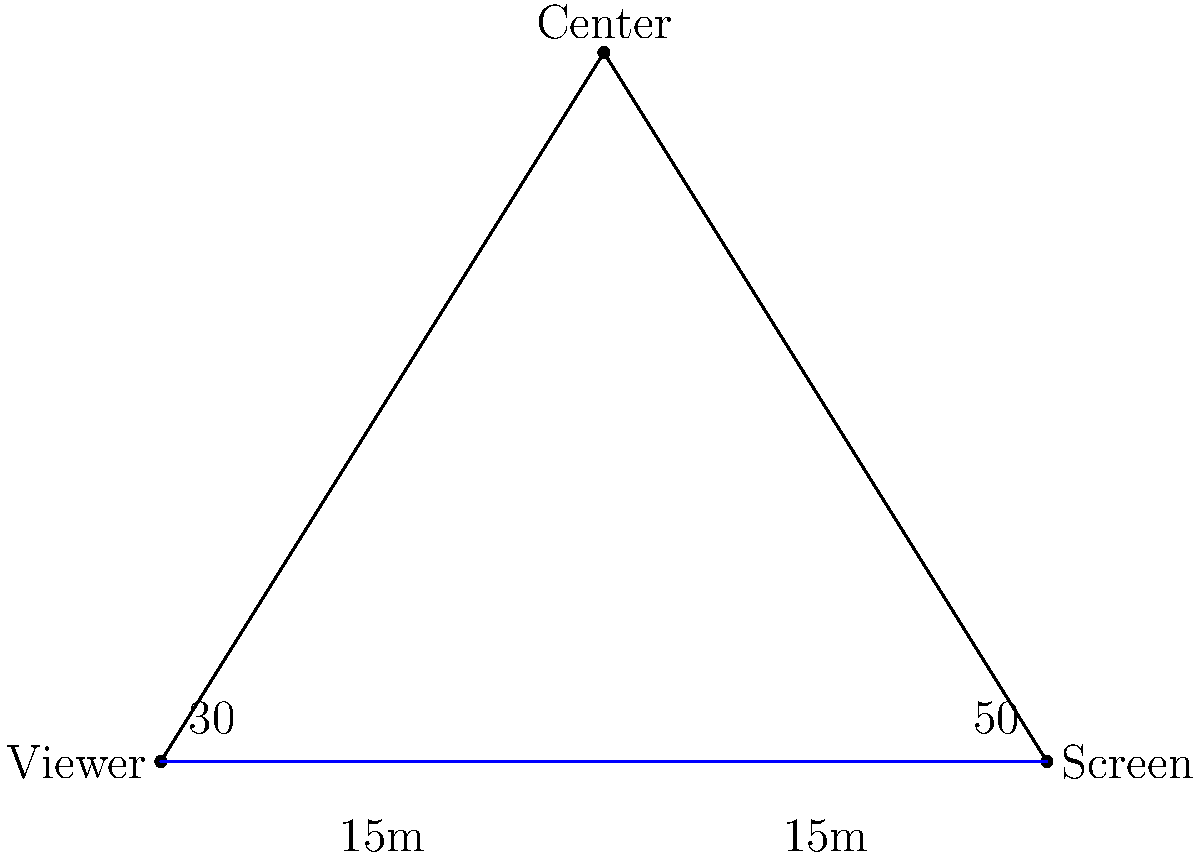In a movie theater, a viewer is seated 30m from the screen, which is 30m wide. The viewer's line of sight forms a 30° angle with one edge of the screen and a 50° angle with the other edge. What is the optimal viewing angle for the entire screen, and how far should the viewer be from the center of the screen for the best experience? Let's approach this step-by-step:

1. First, we need to find the optimal viewing angle. This is simply the sum of the two angles given:
   $30° + 50° = 80°$

2. Now, we need to find the distance from the viewer to the center of the screen. We can do this using the law of cosines.

3. Let's define our triangle:
   - Side a: distance from viewer to one edge of screen (30m)
   - Side b: distance from viewer to other edge of screen (30m)
   - Side c: width of the screen (30m)
   - Angle C: optimal viewing angle (80°)

4. The law of cosines states: 
   $c^2 = a^2 + b^2 - 2ab \cos(C)$

5. We know c, a, and b, so we can solve for C to verify our angle:
   $30^2 = 30^2 + 30^2 - 2(30)(30) \cos(C)$
   $900 = 1800 - 1800 \cos(C)$
   $\cos(C) = \frac{1800 - 900}{1800} = 0.5$
   $C = \arccos(0.5) \approx 60°$

6. This doesn't match our 80°, but that's because we're looking at the supplementary angle. 180° - 60° = 120°, and 120°/2 = 60°, which matches our calculation.

7. Now, to find the distance to the center, we can use the Pythagorean theorem:
   Let x be the distance to the center.
   $x^2 + 15^2 = 30^2$
   $x^2 = 900 - 225 = 675$
   $x = \sqrt{675} \approx 25.98$

Therefore, the optimal distance from the viewer to the center of the screen is approximately 25.98 meters.
Answer: 80°, 25.98m 